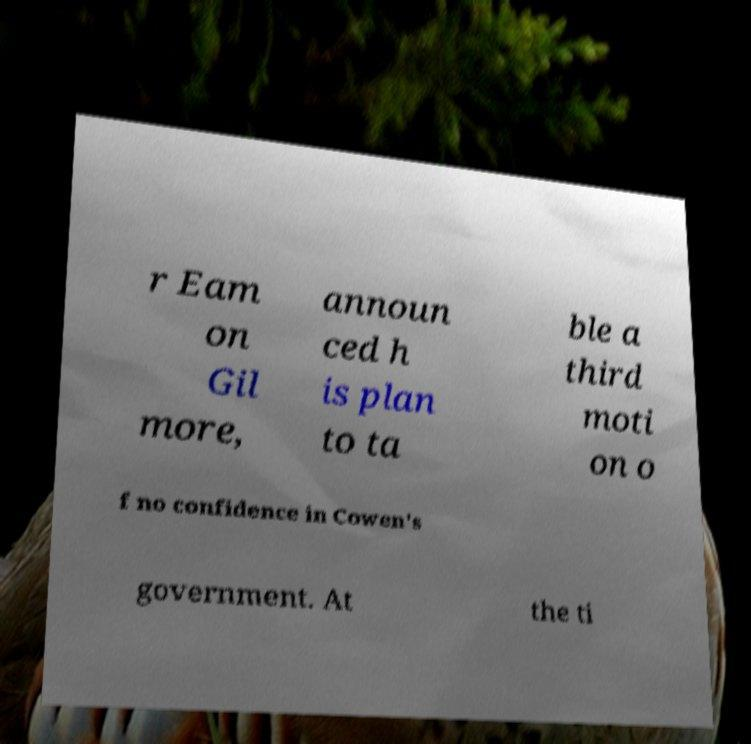Could you extract and type out the text from this image? r Eam on Gil more, announ ced h is plan to ta ble a third moti on o f no confidence in Cowen's government. At the ti 